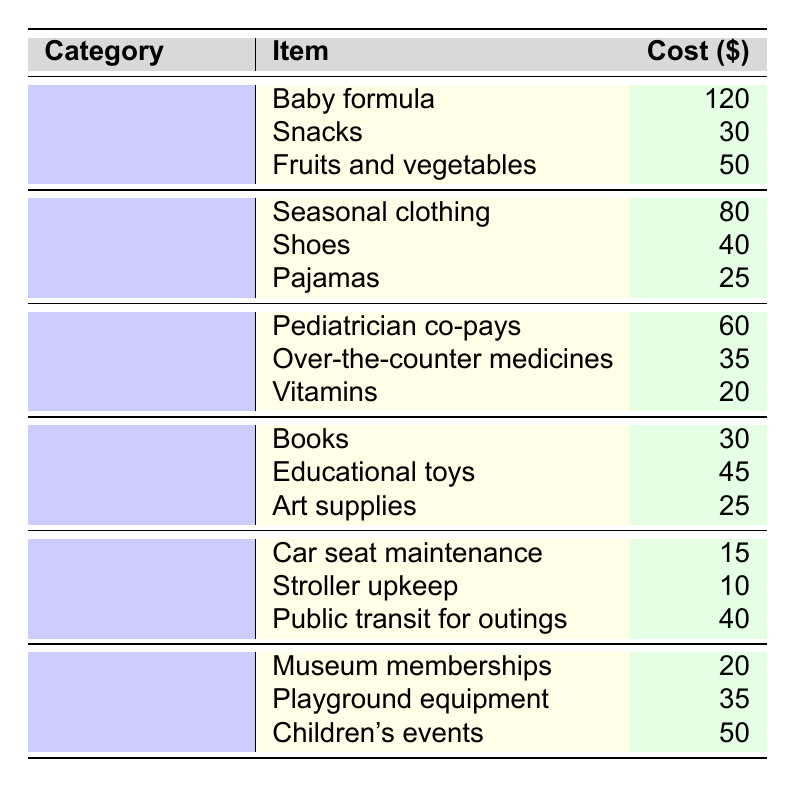What is the total cost of food expenses? To find the total cost in the food category, add the individual costs together: 120 + 30 + 50 = 200.
Answer: 200 Which clothing item is the most expensive? Looking at the clothing category, the costs are 80 for seasonal clothing, 40 for shoes, and 25 for pajamas. The highest cost is 80, corresponding to seasonal clothing.
Answer: Seasonal clothing Are there any transportation expenses that are less than 20 dollars? In the transportation category, the costs are 15, 10, and 40. The items costing 15 and 10 are both less than 20 dollars.
Answer: Yes What is the average cost of healthcare expenses? The healthcare costs are 60, 35, and 20. Adding them gives 60 + 35 + 20 = 115. There are 3 expenses, so the average is 115/3 ≈ 38.33.
Answer: 38.33 Which category has the highest total expenses? Calculate the total for each category: Food = 200, Clothing = 145, Healthcare = 115, Education = 100, Transportation = 65, Entertainment = 105. The highest is food at 200.
Answer: Food How much do snacks cost compared to pediatrician co-pays? Snacks cost 30 and pediatrician co-pays cost 60. The comparison shows that the pediatrician co-pays are higher by 60 - 30 = 30.
Answer: 30 If you wanted to cut entertainment expenses by 50%, how much would you save? The total for entertainment is 20 + 35 + 50 = 105. Cutting this by 50% results in a saving of 105 * 0.5 = 52.5.
Answer: 52.5 Is the total amount spent on clothing greater than that on healthcare? The total for clothing is 145, and for healthcare, it is 115. Since 145 > 115, the statement is true.
Answer: Yes What is the combined cost of fruits and vegetables and educational toys? The cost of fruits and vegetables is 50, and educational toys cost 45. Adding these together gives 50 + 45 = 95.
Answer: 95 If you sum up all expenses across categories, what is the total monthly budget for child-related expenses? The total costs are: Food (200) + Clothing (145) + Healthcare (115) + Education (100) + Transportation (65) + Entertainment (105), which sums up to 200 + 145 + 115 + 100 + 65 + 105 = 730.
Answer: 730 